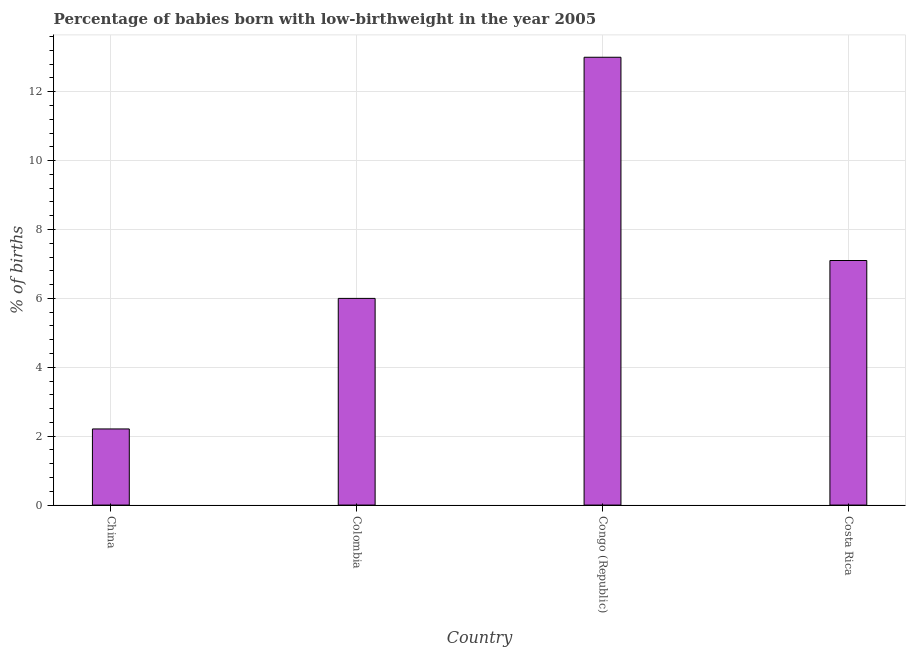Does the graph contain any zero values?
Your answer should be very brief. No. Does the graph contain grids?
Provide a succinct answer. Yes. What is the title of the graph?
Provide a short and direct response. Percentage of babies born with low-birthweight in the year 2005. What is the label or title of the X-axis?
Your answer should be compact. Country. What is the label or title of the Y-axis?
Provide a succinct answer. % of births. What is the percentage of babies who were born with low-birthweight in Congo (Republic)?
Make the answer very short. 13. Across all countries, what is the minimum percentage of babies who were born with low-birthweight?
Your response must be concise. 2.21. In which country was the percentage of babies who were born with low-birthweight maximum?
Give a very brief answer. Congo (Republic). In which country was the percentage of babies who were born with low-birthweight minimum?
Provide a short and direct response. China. What is the sum of the percentage of babies who were born with low-birthweight?
Your answer should be compact. 28.31. What is the average percentage of babies who were born with low-birthweight per country?
Provide a short and direct response. 7.08. What is the median percentage of babies who were born with low-birthweight?
Give a very brief answer. 6.55. In how many countries, is the percentage of babies who were born with low-birthweight greater than 5.2 %?
Your answer should be very brief. 3. What is the ratio of the percentage of babies who were born with low-birthweight in Congo (Republic) to that in Costa Rica?
Offer a terse response. 1.83. Is the percentage of babies who were born with low-birthweight in Congo (Republic) less than that in Costa Rica?
Keep it short and to the point. No. Is the difference between the percentage of babies who were born with low-birthweight in Congo (Republic) and Costa Rica greater than the difference between any two countries?
Offer a terse response. No. What is the difference between the highest and the second highest percentage of babies who were born with low-birthweight?
Give a very brief answer. 5.9. Is the sum of the percentage of babies who were born with low-birthweight in China and Costa Rica greater than the maximum percentage of babies who were born with low-birthweight across all countries?
Ensure brevity in your answer.  No. What is the difference between the highest and the lowest percentage of babies who were born with low-birthweight?
Provide a short and direct response. 10.79. In how many countries, is the percentage of babies who were born with low-birthweight greater than the average percentage of babies who were born with low-birthweight taken over all countries?
Offer a terse response. 2. Are all the bars in the graph horizontal?
Your response must be concise. No. What is the % of births in China?
Provide a short and direct response. 2.21. What is the % of births of Colombia?
Your response must be concise. 6. What is the % of births in Congo (Republic)?
Offer a terse response. 13. What is the % of births in Costa Rica?
Your response must be concise. 7.1. What is the difference between the % of births in China and Colombia?
Ensure brevity in your answer.  -3.79. What is the difference between the % of births in China and Congo (Republic)?
Make the answer very short. -10.79. What is the difference between the % of births in China and Costa Rica?
Offer a terse response. -4.89. What is the difference between the % of births in Colombia and Congo (Republic)?
Your answer should be compact. -7. What is the ratio of the % of births in China to that in Colombia?
Ensure brevity in your answer.  0.37. What is the ratio of the % of births in China to that in Congo (Republic)?
Make the answer very short. 0.17. What is the ratio of the % of births in China to that in Costa Rica?
Your answer should be very brief. 0.31. What is the ratio of the % of births in Colombia to that in Congo (Republic)?
Give a very brief answer. 0.46. What is the ratio of the % of births in Colombia to that in Costa Rica?
Ensure brevity in your answer.  0.84. What is the ratio of the % of births in Congo (Republic) to that in Costa Rica?
Give a very brief answer. 1.83. 